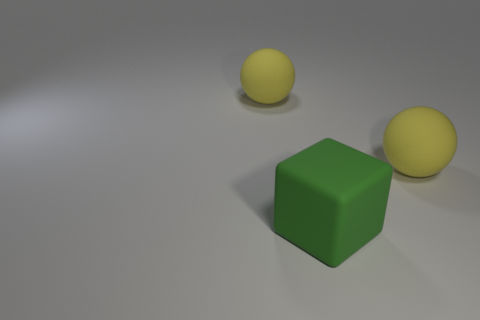Are there more big yellow rubber balls behind the green cube than tiny red cubes? Yes, there are more big yellow rubber balls behind the green cube, as we can observe two of them compared to the absence of tiny red cubes in view. 